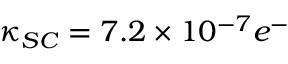Convert formula to latex. <formula><loc_0><loc_0><loc_500><loc_500>\kappa _ { S C } = 7 . 2 \times 1 0 ^ { - 7 } e ^ { - }</formula> 